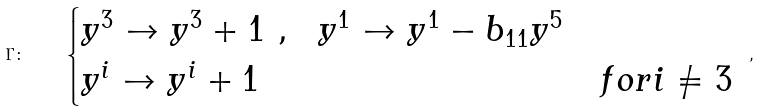<formula> <loc_0><loc_0><loc_500><loc_500>\Gamma \colon \quad \begin{cases} y ^ { 3 } \to y ^ { 3 } + 1 \ , \ \ y ^ { 1 } \to y ^ { 1 } - b _ { 1 1 } y ^ { 5 } & \\ y ^ { i } \to y ^ { i } + 1 & f o r i \neq 3 \end{cases} \ ,</formula> 